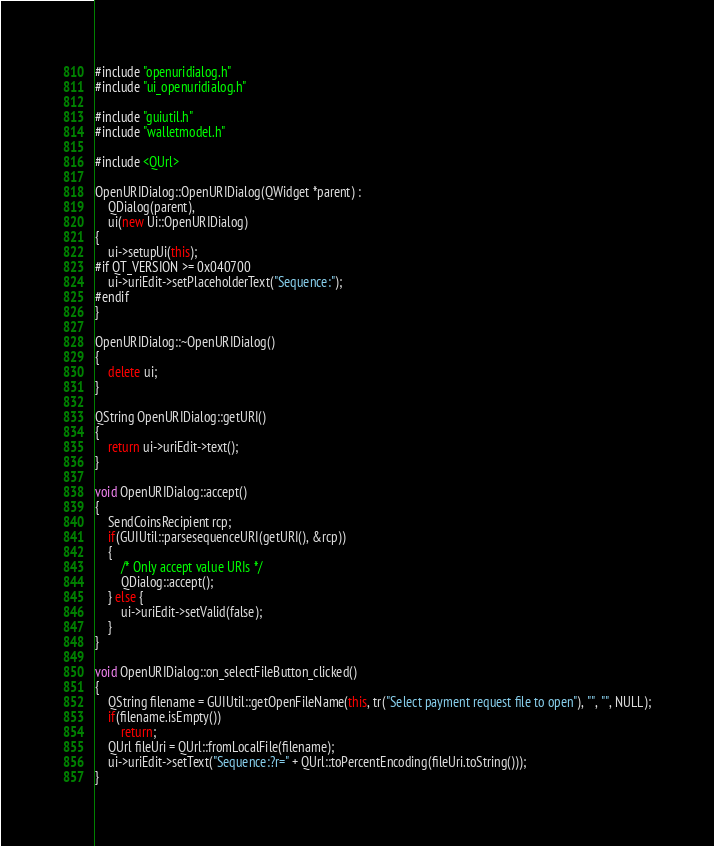Convert code to text. <code><loc_0><loc_0><loc_500><loc_500><_C++_>
#include "openuridialog.h"
#include "ui_openuridialog.h"

#include "guiutil.h"
#include "walletmodel.h"

#include <QUrl>

OpenURIDialog::OpenURIDialog(QWidget *parent) :
    QDialog(parent),
    ui(new Ui::OpenURIDialog)
{
    ui->setupUi(this);
#if QT_VERSION >= 0x040700
    ui->uriEdit->setPlaceholderText("Sequence:");
#endif
}

OpenURIDialog::~OpenURIDialog()
{
    delete ui;
}

QString OpenURIDialog::getURI()
{
    return ui->uriEdit->text();
}

void OpenURIDialog::accept()
{
    SendCoinsRecipient rcp;
    if(GUIUtil::parsesequenceURI(getURI(), &rcp))
    {
        /* Only accept value URIs */
        QDialog::accept();
    } else {
        ui->uriEdit->setValid(false);
    }
}

void OpenURIDialog::on_selectFileButton_clicked()
{
    QString filename = GUIUtil::getOpenFileName(this, tr("Select payment request file to open"), "", "", NULL);
    if(filename.isEmpty())
        return;
    QUrl fileUri = QUrl::fromLocalFile(filename);
    ui->uriEdit->setText("Sequence:?r=" + QUrl::toPercentEncoding(fileUri.toString()));
}
</code> 